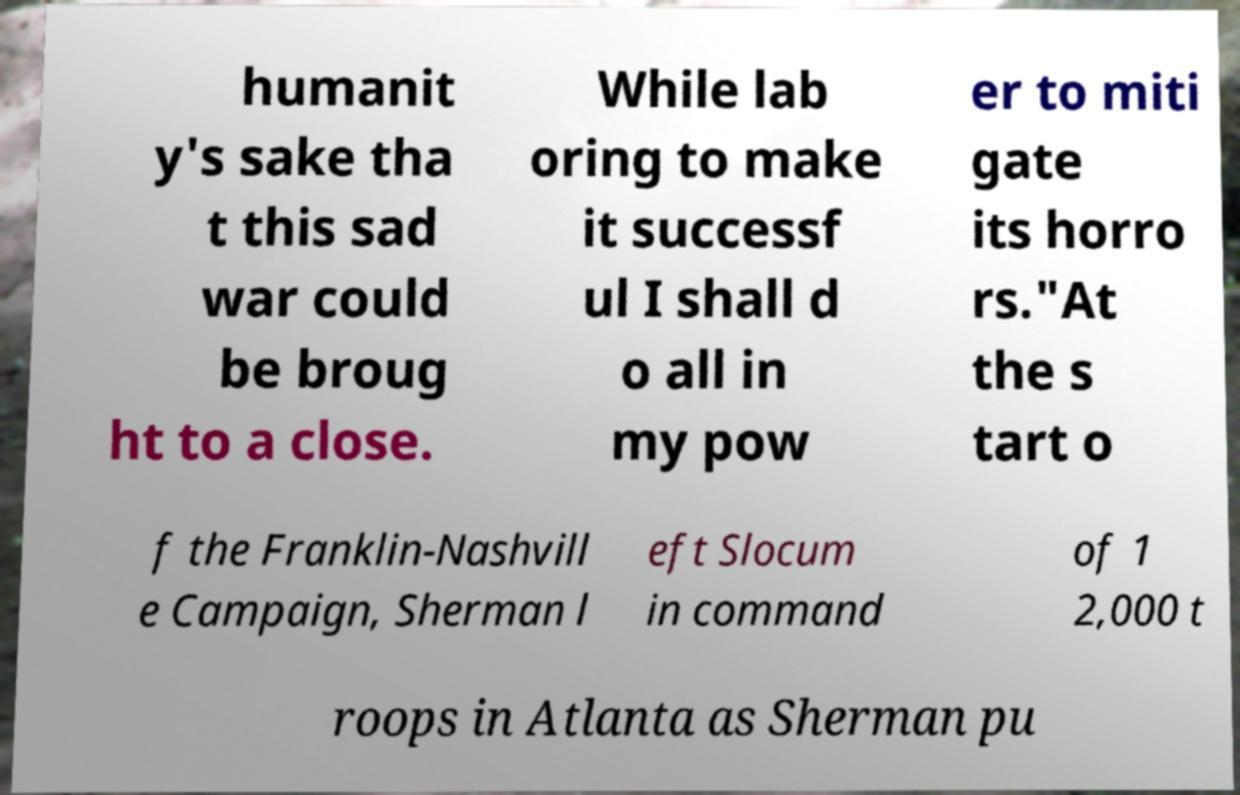Can you accurately transcribe the text from the provided image for me? humanit y's sake tha t this sad war could be broug ht to a close. While lab oring to make it successf ul I shall d o all in my pow er to miti gate its horro rs."At the s tart o f the Franklin-Nashvill e Campaign, Sherman l eft Slocum in command of 1 2,000 t roops in Atlanta as Sherman pu 